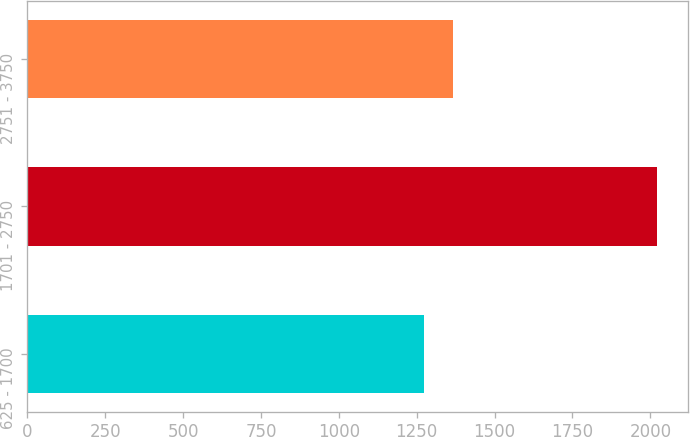Convert chart. <chart><loc_0><loc_0><loc_500><loc_500><bar_chart><fcel>625 - 1700<fcel>1701 - 2750<fcel>2751 - 3750<nl><fcel>1275<fcel>2021<fcel>1367<nl></chart> 